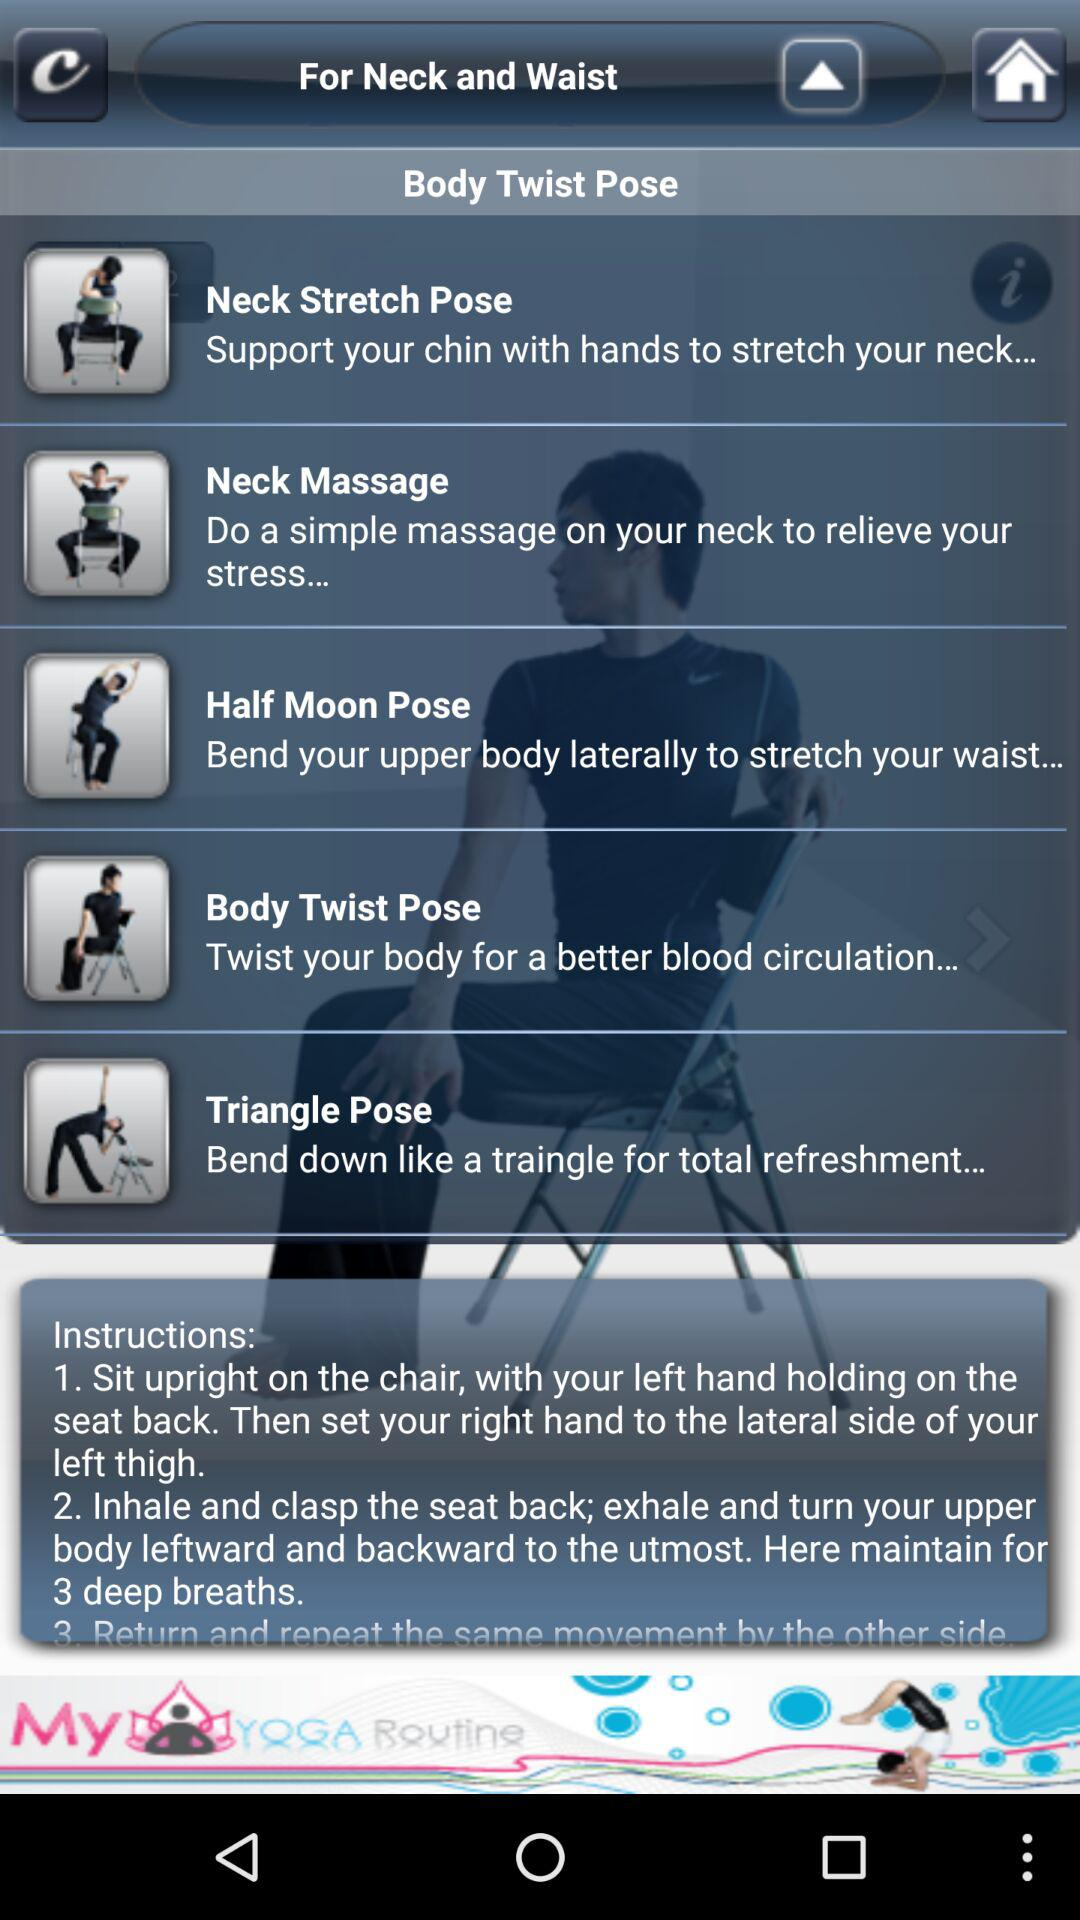Which pose is suitable for total refreshment? The pose that is suitable for total refreshment is "Triangle Pose". 